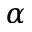Convert formula to latex. <formula><loc_0><loc_0><loc_500><loc_500>\alpha</formula> 